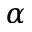Convert formula to latex. <formula><loc_0><loc_0><loc_500><loc_500>\alpha</formula> 